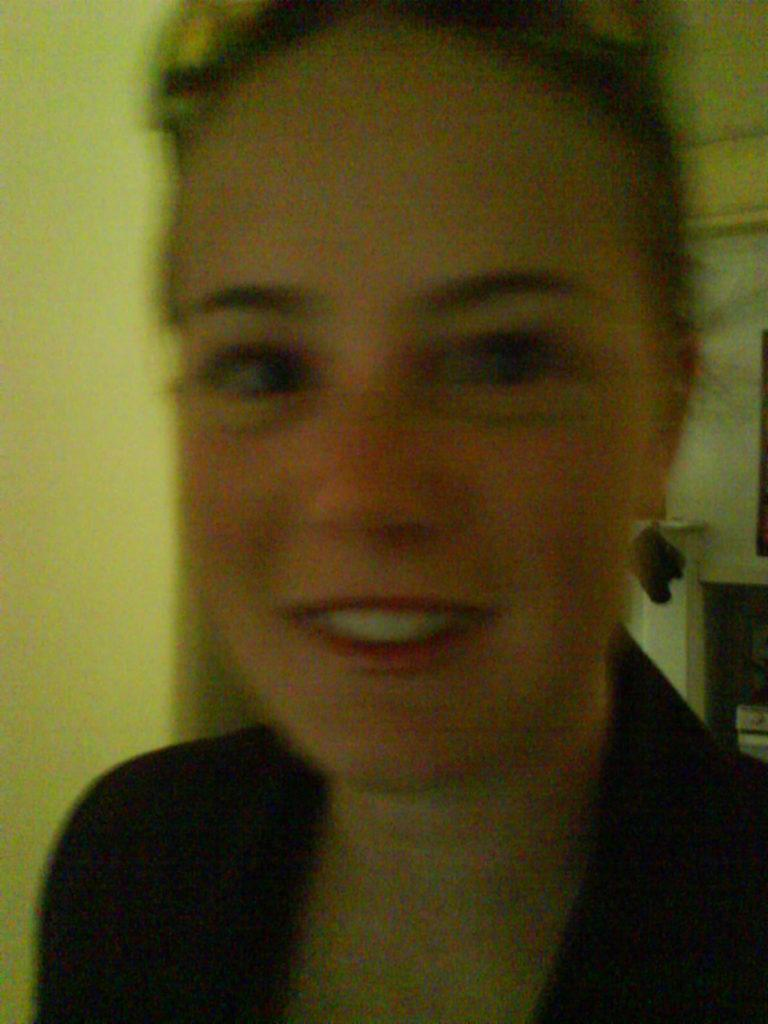Who is present in the image? There is a lady in the image. What can be seen in the background of the image? There is a wall in the background of the image. Where is the boy playing with beads in the image? There is no boy or beads present in the image; it only features a lady. What type of wrench can be seen in the image? There is no wrench present in the image. 